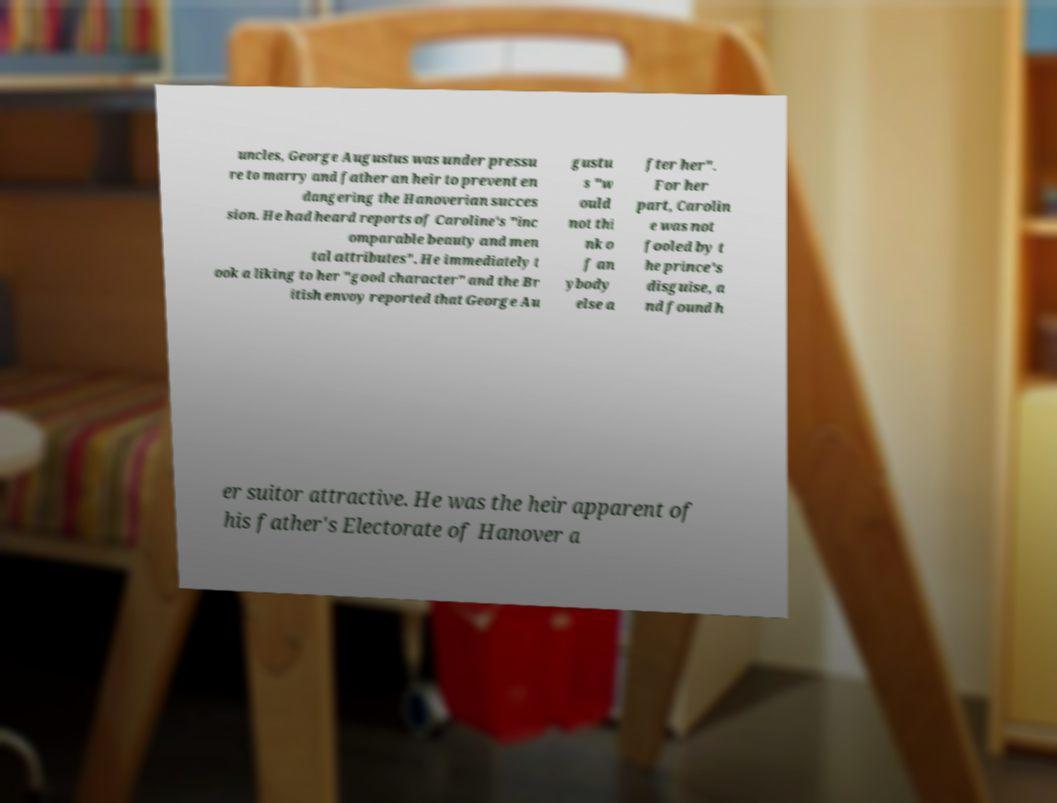There's text embedded in this image that I need extracted. Can you transcribe it verbatim? uncles, George Augustus was under pressu re to marry and father an heir to prevent en dangering the Hanoverian succes sion. He had heard reports of Caroline's "inc omparable beauty and men tal attributes". He immediately t ook a liking to her "good character" and the Br itish envoy reported that George Au gustu s "w ould not thi nk o f an ybody else a fter her". For her part, Carolin e was not fooled by t he prince's disguise, a nd found h er suitor attractive. He was the heir apparent of his father's Electorate of Hanover a 